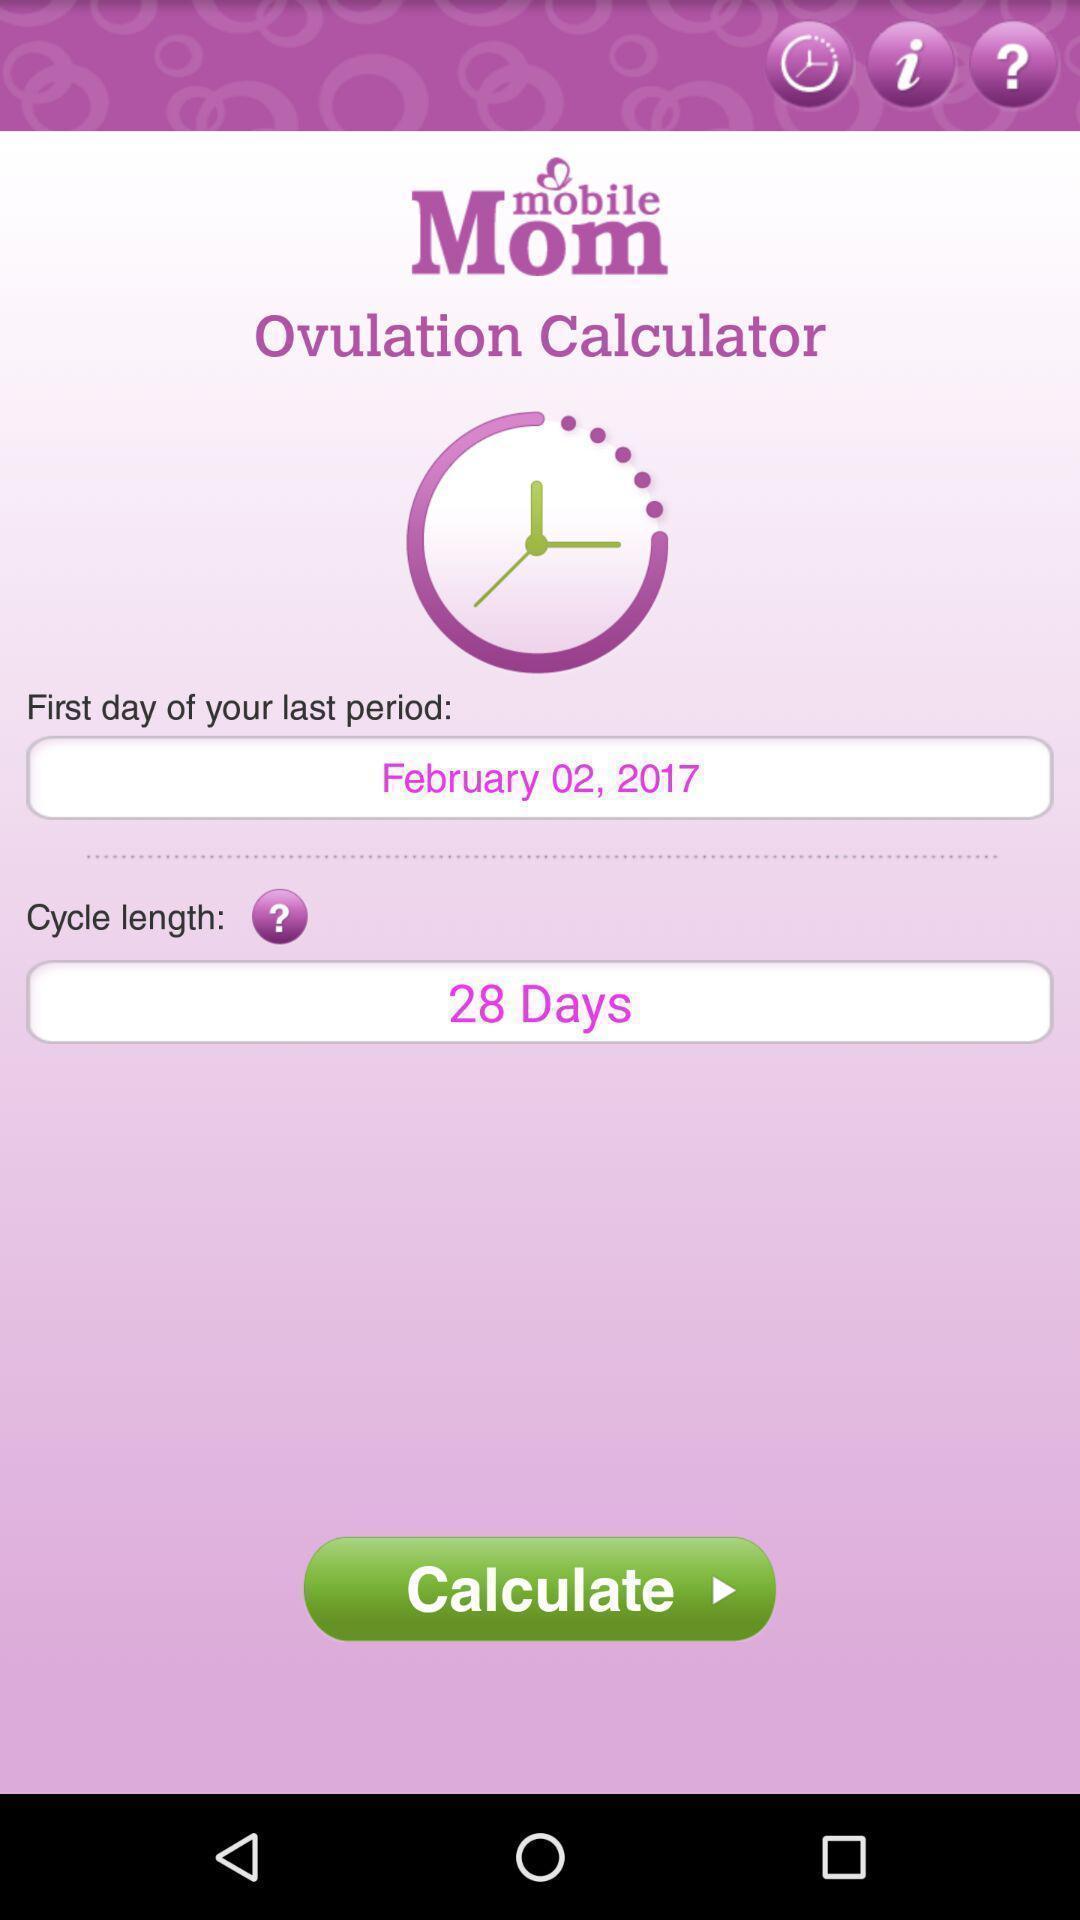Please provide a description for this image. Page displaying the ovulation calculator. 